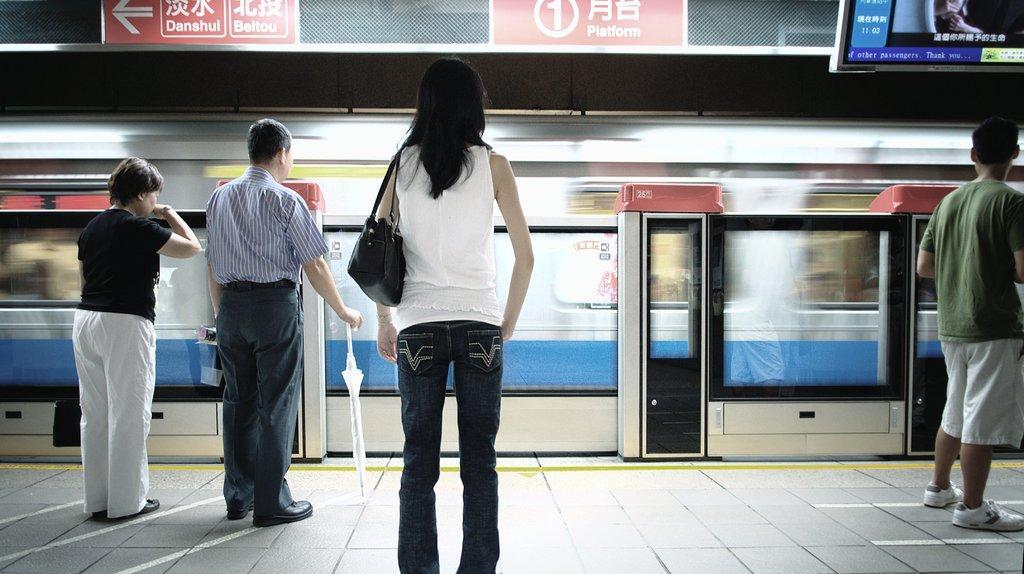Can you describe this image briefly? In this picture we can see a woman wearing a white top standing on the railway station. Behind there is an old man and woman, standing and waiting for the train. Behind there is a train passing from track. 